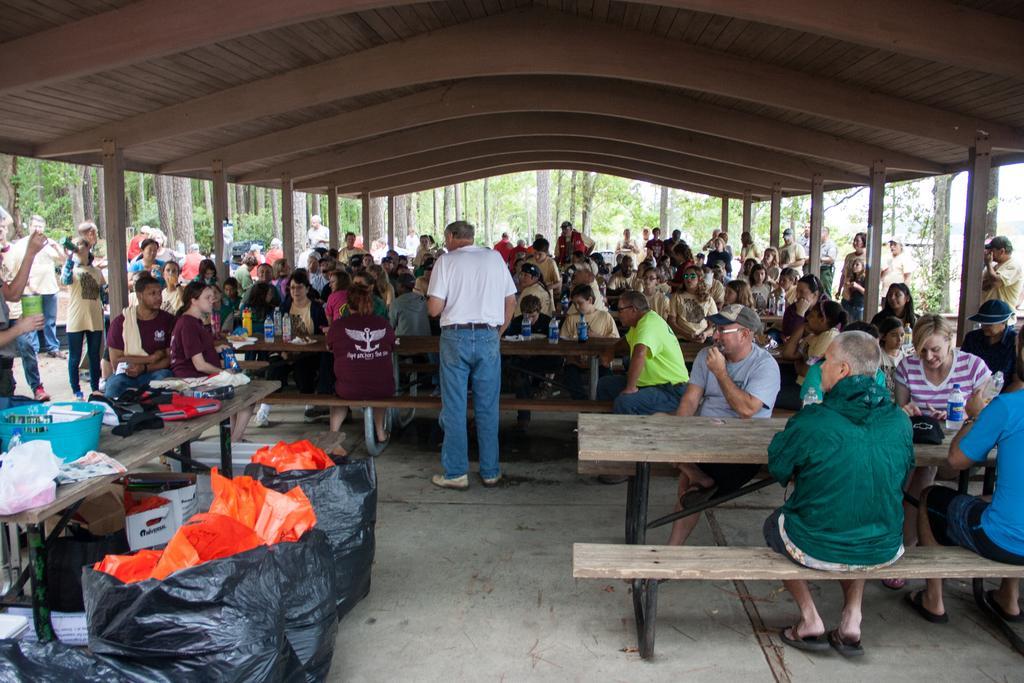Please provide a concise description of this image. Here in the middle there is a man standing. In the background there are few people sitting on the benches at the table and few are standing. On the table we can see water bottles and few other items and we can also see trees and sky. On the left there are bags on the floor and on the table there are some items and basket. 